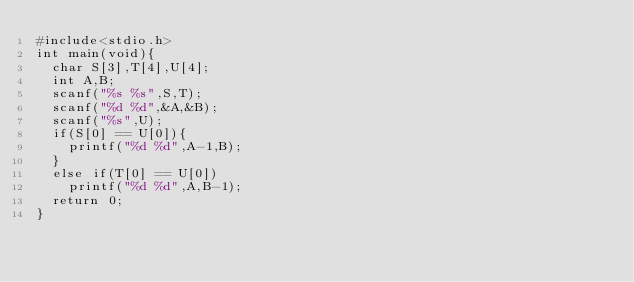Convert code to text. <code><loc_0><loc_0><loc_500><loc_500><_C_>#include<stdio.h>
int main(void){
  char S[3],T[4],U[4];
  int A,B;
  scanf("%s %s",S,T);
  scanf("%d %d",&A,&B);
  scanf("%s",U);
  if(S[0] == U[0]){
		printf("%d %d",A-1,B);
  }
  else if(T[0] == U[0])
    printf("%d %d",A,B-1);
  return 0;
}</code> 